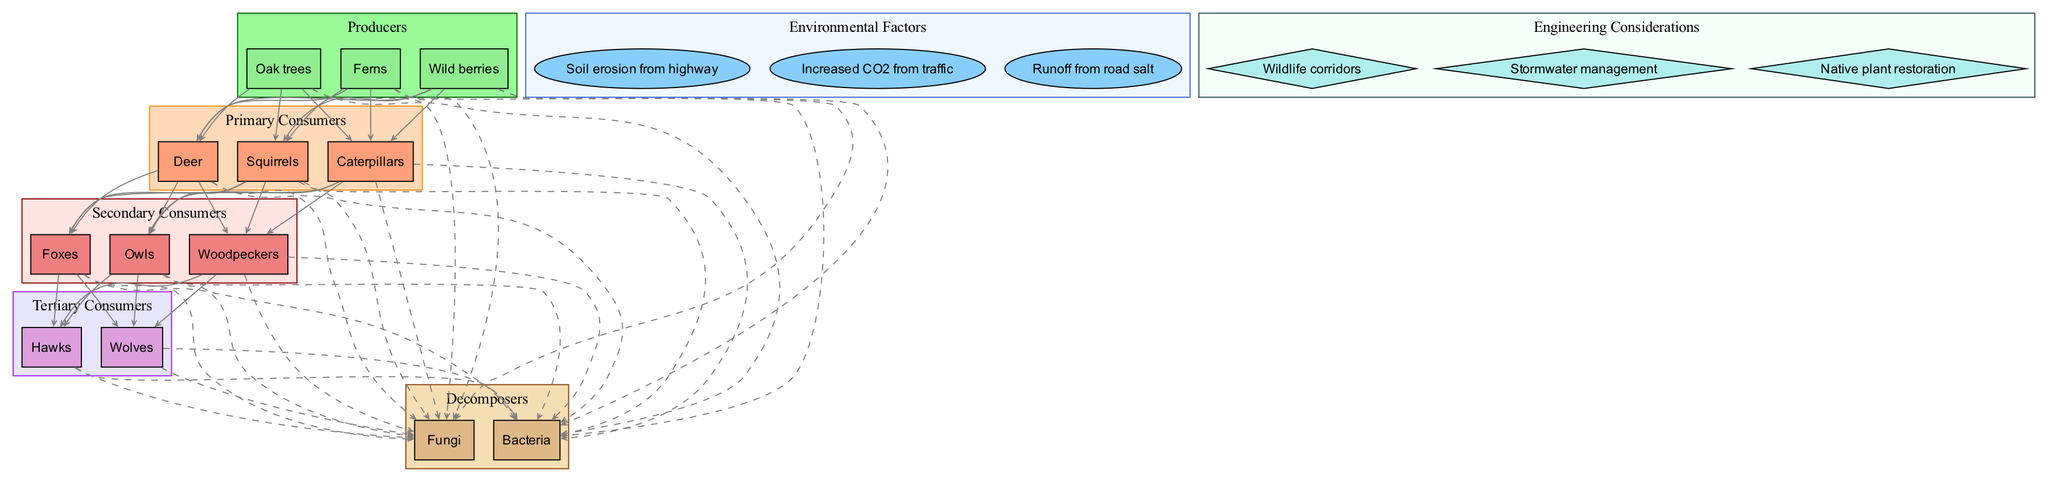What are the producers in the forest ecosystem? The producers are listed in the diagram, which includes oak trees, ferns, and wild berries, all plants that convert sunlight into energy through photosynthesis.
Answer: Oak trees, ferns, wild berries How many primary consumers are identified? By counting the nodes under the primary consumers section, we identify three primary consumers: deer, squirrels, and caterpillars, which rely on producers for food.
Answer: 3 Which organism is a tertiary consumer? The tertiary consumers are listed in the diagram as hawks and wolves. Being at the top level of the food chain, they prey on secondary consumers.
Answer: Hawks, wolves What is one environmental factor affecting the ecosystem due to highway development? The diagram mentions several environmental factors; one example is increased CO2 from traffic, which contributes to climate change and affects forest health.
Answer: Increased CO2 from traffic Which consumer directly feeds on caterpillars? The diagram shows a direct feeding relationship where secondary consumers like foxes, owls, and woodpeckers eat primary consumers such as caterpillars.
Answer: Foxes, owls, woodpeckers How do decomposers contribute to the nutrient cycle? Decomposers like fungi and bacteria break down dead organic material from producers and consumers, returning essential nutrients back into the soil for producers, thereby maintaining the cycle.
Answer: Break down dead material What type of management is suggested to mitigate highway impact? The diagram indicates stormwater management as an engineering consideration to control runoff and protect the forest ecosystem from potential pollution caused by the highway.
Answer: Stormwater management Which consumer levels are at risk from soil erosion caused by highway construction? Both primary and secondary consumers are at risk; primary consumers like deer and secondary consumers like foxes depend on the soil for vegetation that constitutes their food source.
Answer: Primary and secondary consumers How many decomposers are listed in the diagram? By reviewing the decomposers section, we see there are two decomposers: fungi and bacteria which play a crucial role in nutrient cycling.
Answer: 2 